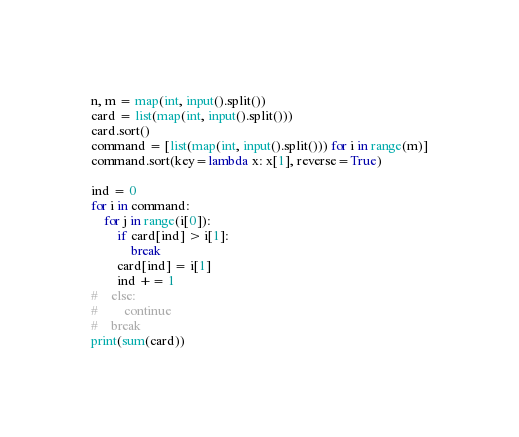<code> <loc_0><loc_0><loc_500><loc_500><_Python_>n, m = map(int, input().split()) 
card = list(map(int, input().split()))
card.sort()
command = [list(map(int, input().split())) for i in range(m)]
command.sort(key=lambda x: x[1], reverse=True)

ind = 0
for i in command:
    for j in range(i[0]):
        if card[ind] > i[1]:
            break
        card[ind] = i[1]
        ind += 1
#    else:
#        continue
#    break
print(sum(card))</code> 